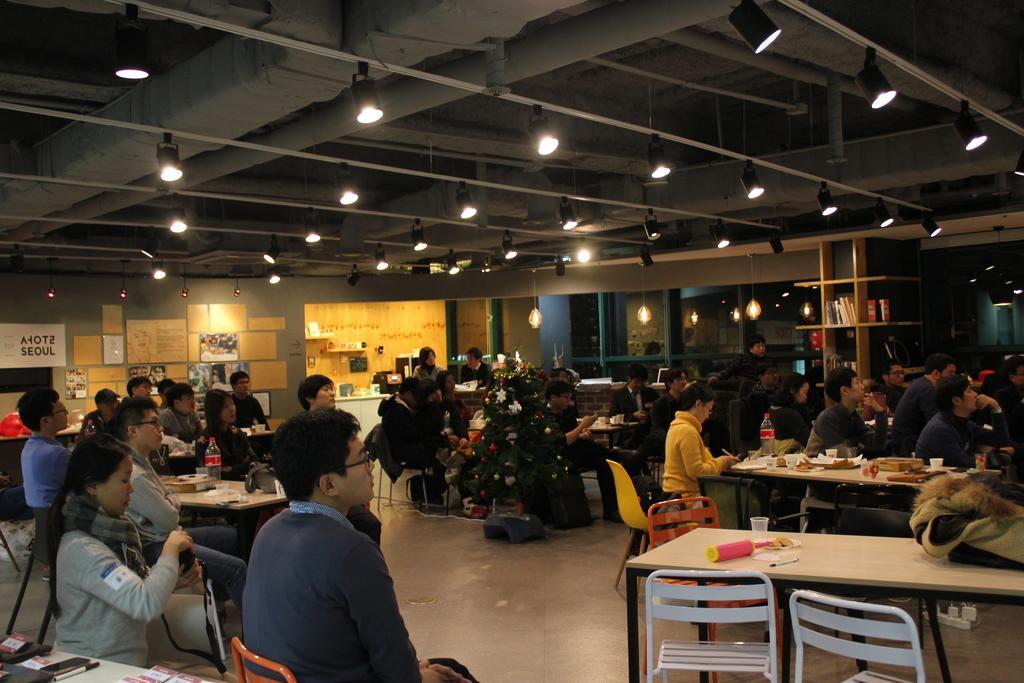Could you give a brief overview of what you see in this image? In the image there are many people sitting on the chairs and also there are tables with bottles, glasses, jackets and many other things. In the background there are walls with posters, papers, frames and some other things. And also there is a cupboard with few things in it. And in the background there are glass walls. At the top of the image there is ceiling with chimneys and lights. 